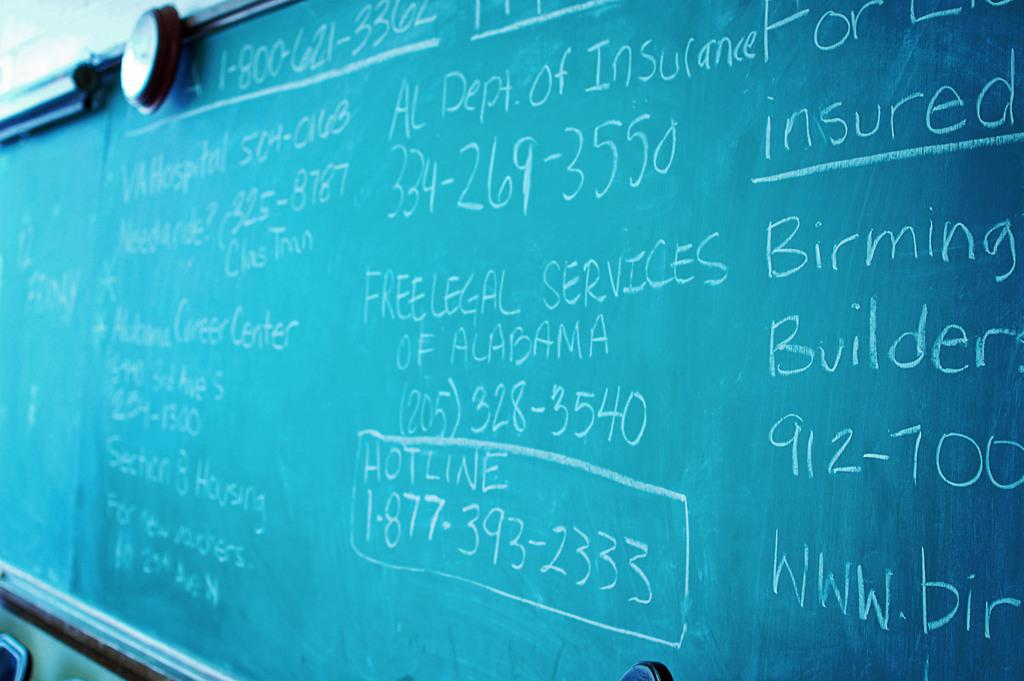<image>
Relay a brief, clear account of the picture shown. A green chalkboard that is covered in writing, some of which says Free Legal Services of Alabama. 